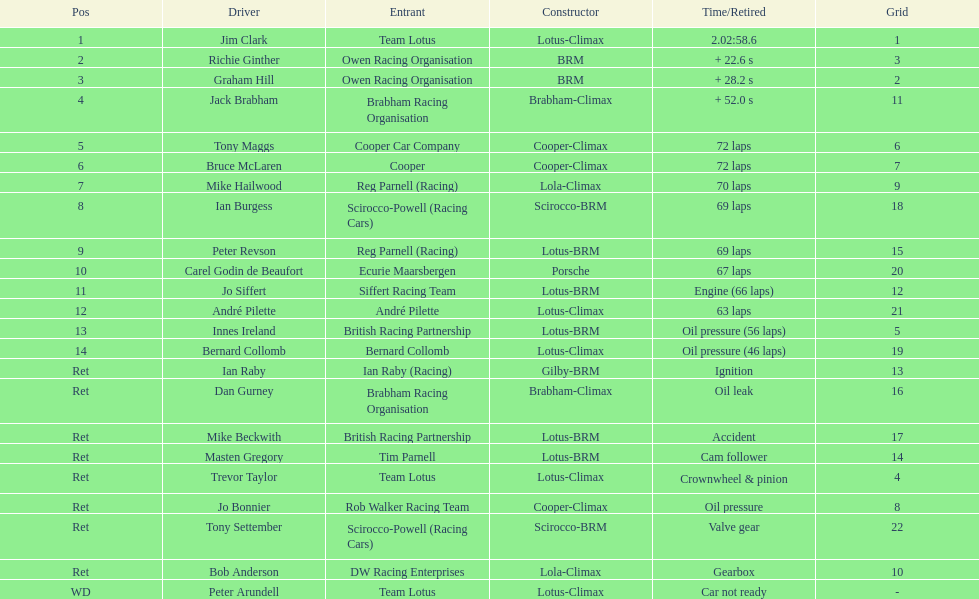Who were the competitors at the 1963 international gold cup? Jim Clark, Richie Ginther, Graham Hill, Jack Brabham, Tony Maggs, Bruce McLaren, Mike Hailwood, Ian Burgess, Peter Revson, Carel Godin de Beaufort, Jo Siffert, André Pilette, Innes Ireland, Bernard Collomb, Ian Raby, Dan Gurney, Mike Beckwith, Masten Gregory, Trevor Taylor, Jo Bonnier, Tony Settember, Bob Anderson, Peter Arundell. What position did tony maggs achieve? 5. What about jo siffert? 11. Who arrived earlier? Tony Maggs. 